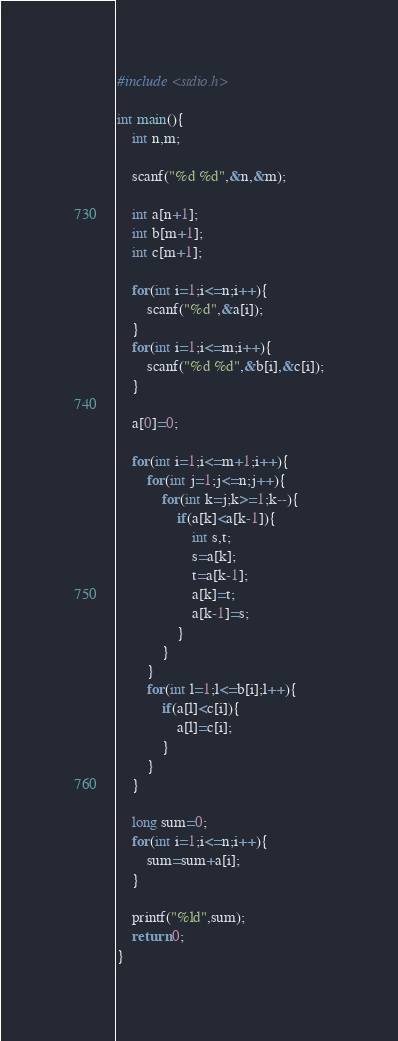Convert code to text. <code><loc_0><loc_0><loc_500><loc_500><_C_>#include <stdio.h>

int main(){
    int n,m;
    
    scanf("%d %d",&n,&m);
    
    int a[n+1];
    int b[m+1];
    int c[m+1];
    
    for(int i=1;i<=n;i++){
        scanf("%d",&a[i]);
    }
    for(int i=1;i<=m;i++){
        scanf("%d %d",&b[i],&c[i]);
    }
    
    a[0]=0;
    
    for(int i=1;i<=m+1;i++){
        for(int j=1;j<=n;j++){
            for(int k=j;k>=1;k--){
                if(a[k]<a[k-1]){
                    int s,t;
                    s=a[k];
                    t=a[k-1];
                    a[k]=t;
                    a[k-1]=s;
                }
            }
        }
        for(int l=1;l<=b[i];l++){
            if(a[l]<c[i]){
                a[l]=c[i];
            }
        }
    }
    
    long sum=0;
    for(int i=1;i<=n;i++){
        sum=sum+a[i];
    }
    
    printf("%ld",sum);
    return 0;
}

</code> 